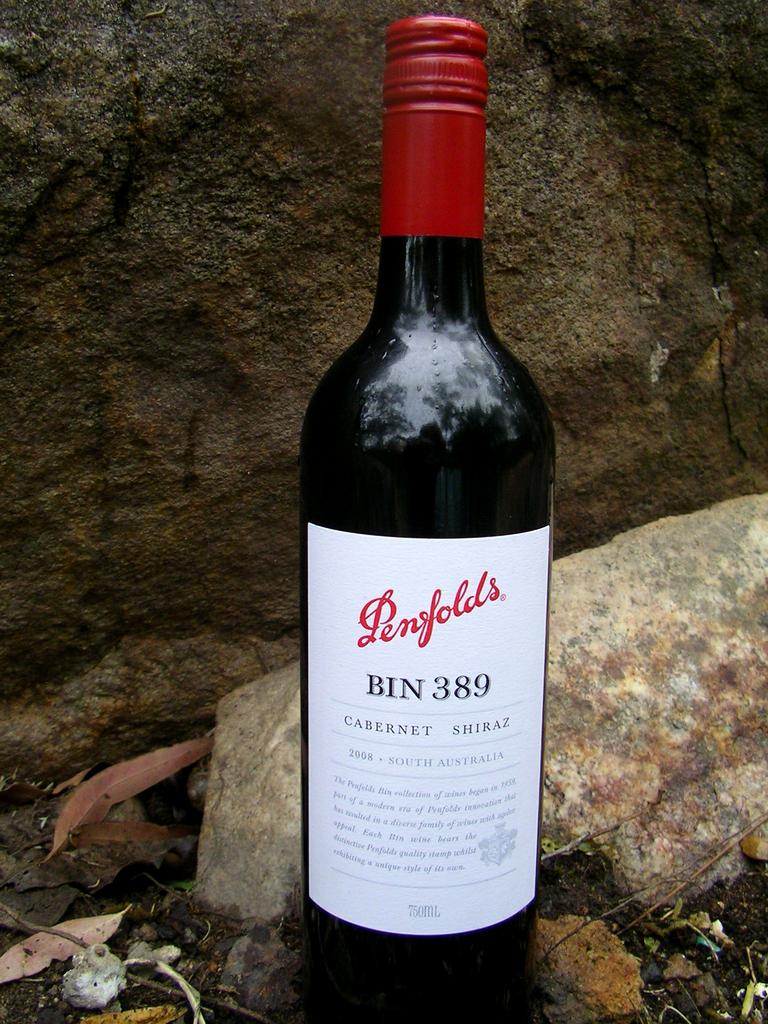What bin did the wine come from?
Keep it short and to the point. 389. What brand of wine?
Ensure brevity in your answer.  Penfolds. 